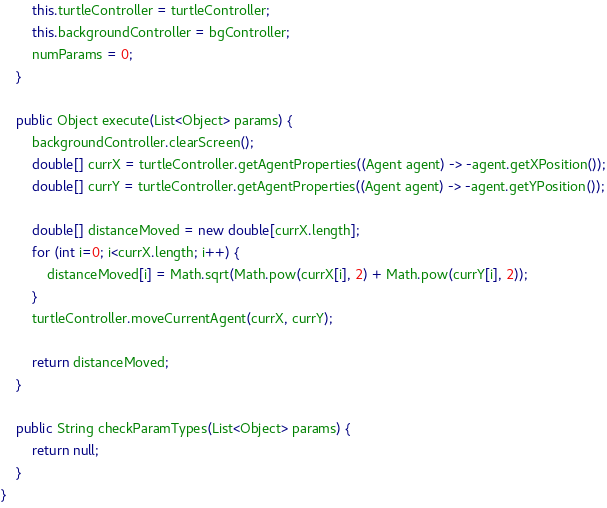Convert code to text. <code><loc_0><loc_0><loc_500><loc_500><_Java_>		this.turtleController = turtleController;
		this.backgroundController = bgController;
		numParams = 0;
	}

	public Object execute(List<Object> params) {
		backgroundController.clearScreen();
		double[] currX = turtleController.getAgentProperties((Agent agent) -> -agent.getXPosition());
		double[] currY = turtleController.getAgentProperties((Agent agent) -> -agent.getYPosition());
		
		double[] distanceMoved = new double[currX.length];
		for (int i=0; i<currX.length; i++) {
			distanceMoved[i] = Math.sqrt(Math.pow(currX[i], 2) + Math.pow(currY[i], 2));
		}
		turtleController.moveCurrentAgent(currX, currY);
		
		return distanceMoved;
	}

	public String checkParamTypes(List<Object> params) {
		return null;
	}
}</code> 